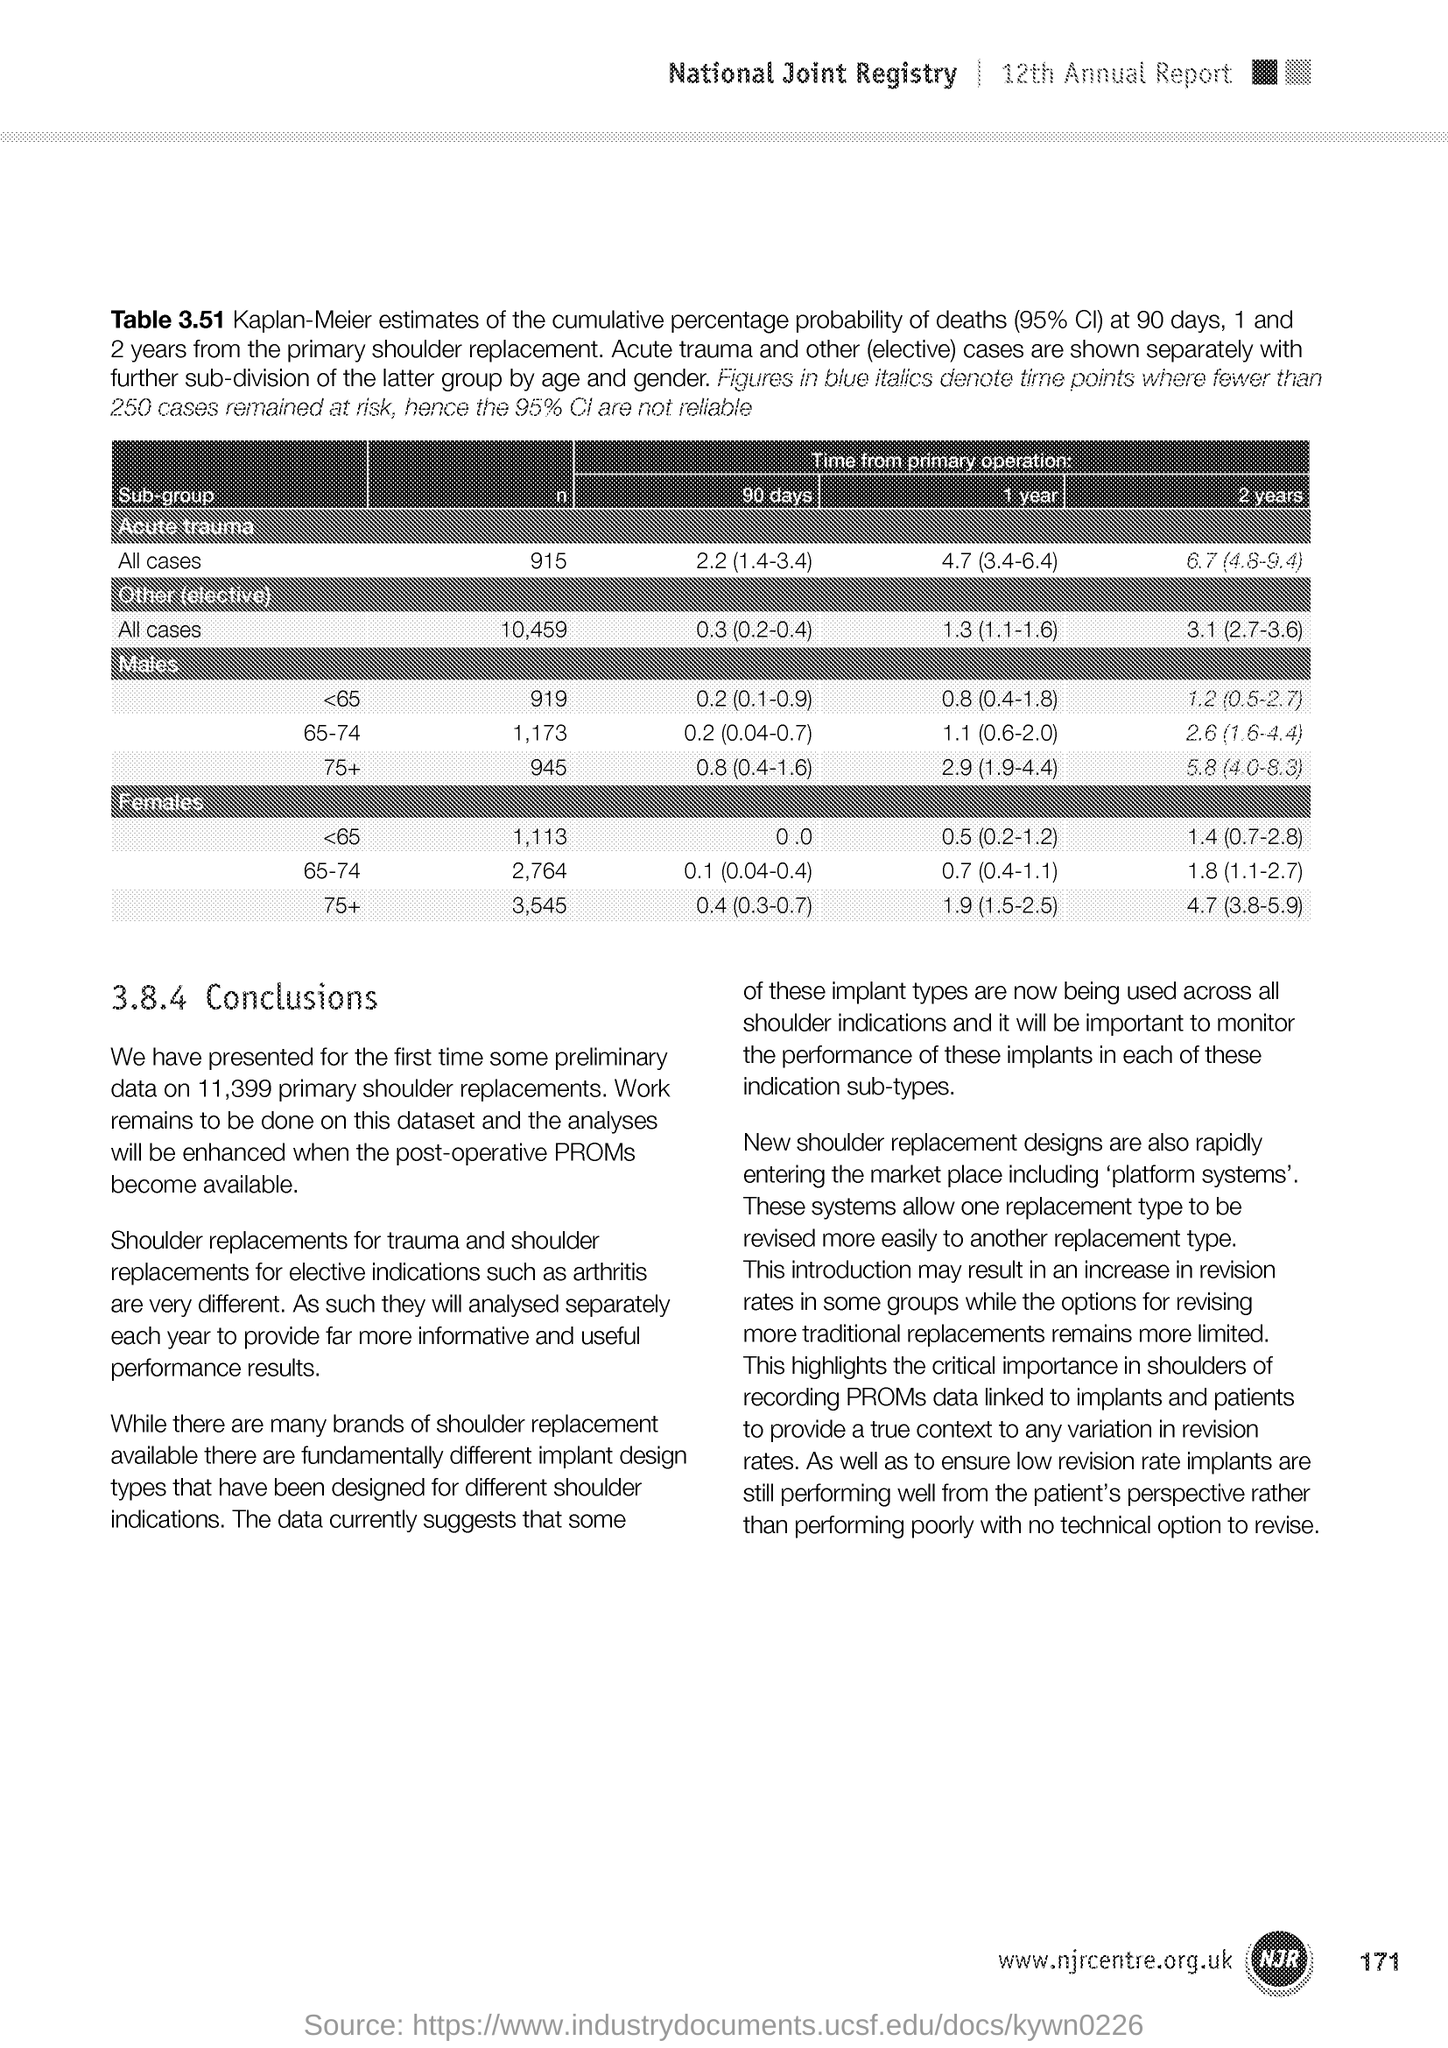Give some essential details in this illustration. What is the page number to which the text refers? It is 171.. 